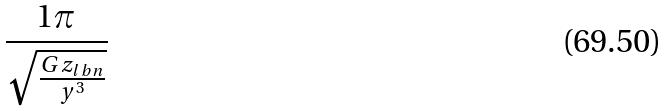Convert formula to latex. <formula><loc_0><loc_0><loc_500><loc_500>\frac { 1 \pi } { \sqrt { \frac { G z _ { l b n } } { y ^ { 3 } } } }</formula> 